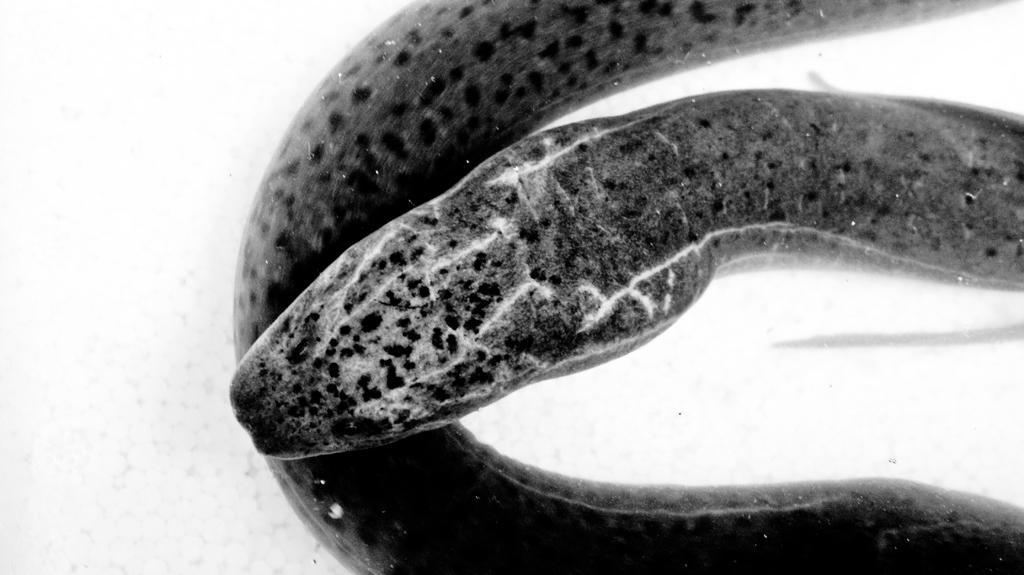Please provide a concise description of this image. In this image I can see a snake. This is a black and white image. 